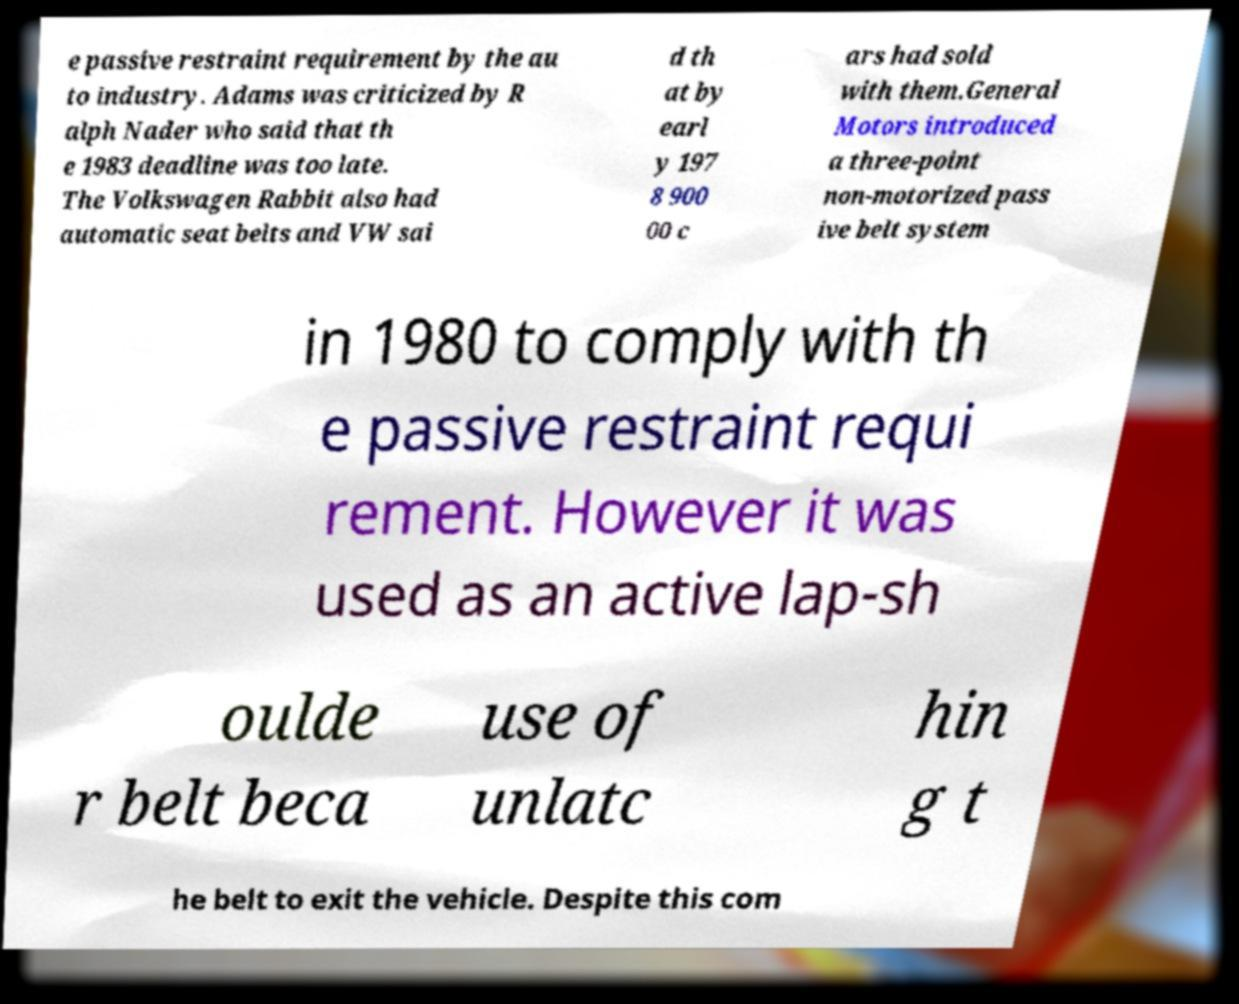Please read and relay the text visible in this image. What does it say? e passive restraint requirement by the au to industry. Adams was criticized by R alph Nader who said that th e 1983 deadline was too late. The Volkswagen Rabbit also had automatic seat belts and VW sai d th at by earl y 197 8 900 00 c ars had sold with them.General Motors introduced a three-point non-motorized pass ive belt system in 1980 to comply with th e passive restraint requi rement. However it was used as an active lap-sh oulde r belt beca use of unlatc hin g t he belt to exit the vehicle. Despite this com 